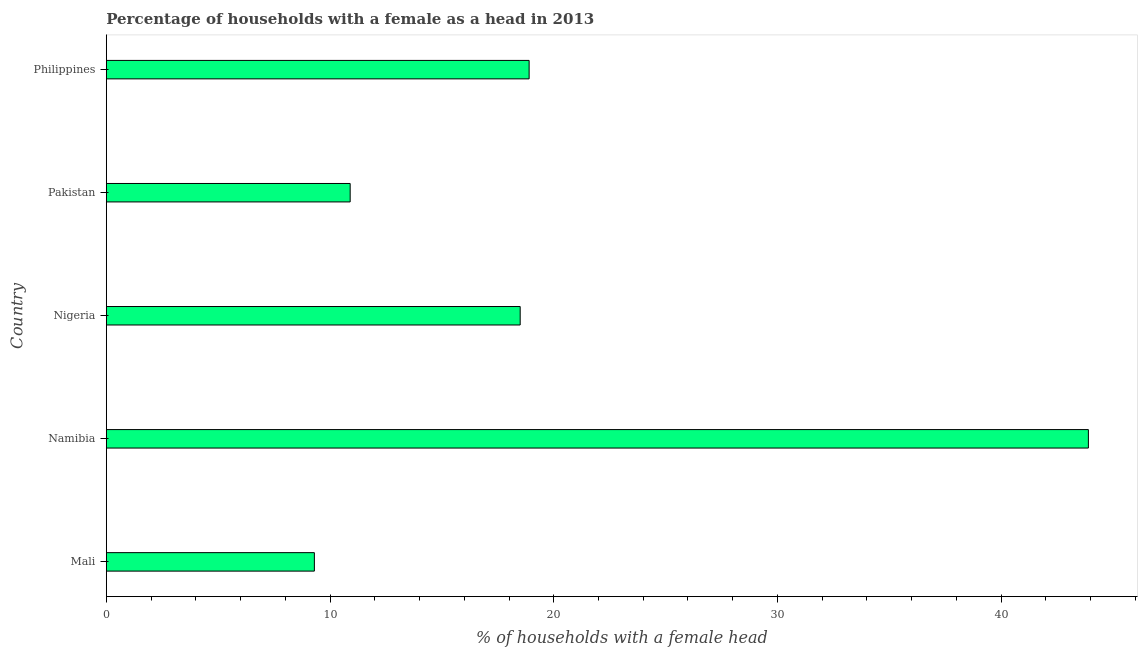Does the graph contain any zero values?
Your answer should be very brief. No. Does the graph contain grids?
Ensure brevity in your answer.  No. What is the title of the graph?
Provide a short and direct response. Percentage of households with a female as a head in 2013. What is the label or title of the X-axis?
Your answer should be compact. % of households with a female head. What is the number of female supervised households in Philippines?
Offer a terse response. 18.9. Across all countries, what is the maximum number of female supervised households?
Your answer should be very brief. 43.9. Across all countries, what is the minimum number of female supervised households?
Provide a succinct answer. 9.3. In which country was the number of female supervised households maximum?
Your answer should be compact. Namibia. In which country was the number of female supervised households minimum?
Make the answer very short. Mali. What is the sum of the number of female supervised households?
Ensure brevity in your answer.  101.5. What is the difference between the number of female supervised households in Namibia and Nigeria?
Make the answer very short. 25.4. What is the average number of female supervised households per country?
Offer a terse response. 20.3. What is the median number of female supervised households?
Your answer should be very brief. 18.5. What is the ratio of the number of female supervised households in Nigeria to that in Philippines?
Your answer should be compact. 0.98. What is the difference between the highest and the second highest number of female supervised households?
Make the answer very short. 25. What is the difference between the highest and the lowest number of female supervised households?
Your answer should be very brief. 34.6. In how many countries, is the number of female supervised households greater than the average number of female supervised households taken over all countries?
Give a very brief answer. 1. What is the difference between two consecutive major ticks on the X-axis?
Your answer should be compact. 10. Are the values on the major ticks of X-axis written in scientific E-notation?
Your answer should be compact. No. What is the % of households with a female head in Mali?
Make the answer very short. 9.3. What is the % of households with a female head in Namibia?
Provide a short and direct response. 43.9. What is the % of households with a female head in Philippines?
Offer a very short reply. 18.9. What is the difference between the % of households with a female head in Mali and Namibia?
Make the answer very short. -34.6. What is the difference between the % of households with a female head in Mali and Philippines?
Make the answer very short. -9.6. What is the difference between the % of households with a female head in Namibia and Nigeria?
Ensure brevity in your answer.  25.4. What is the difference between the % of households with a female head in Namibia and Pakistan?
Keep it short and to the point. 33. What is the difference between the % of households with a female head in Namibia and Philippines?
Give a very brief answer. 25. What is the difference between the % of households with a female head in Pakistan and Philippines?
Provide a succinct answer. -8. What is the ratio of the % of households with a female head in Mali to that in Namibia?
Provide a succinct answer. 0.21. What is the ratio of the % of households with a female head in Mali to that in Nigeria?
Keep it short and to the point. 0.5. What is the ratio of the % of households with a female head in Mali to that in Pakistan?
Your answer should be very brief. 0.85. What is the ratio of the % of households with a female head in Mali to that in Philippines?
Offer a terse response. 0.49. What is the ratio of the % of households with a female head in Namibia to that in Nigeria?
Your answer should be compact. 2.37. What is the ratio of the % of households with a female head in Namibia to that in Pakistan?
Keep it short and to the point. 4.03. What is the ratio of the % of households with a female head in Namibia to that in Philippines?
Provide a succinct answer. 2.32. What is the ratio of the % of households with a female head in Nigeria to that in Pakistan?
Your answer should be compact. 1.7. What is the ratio of the % of households with a female head in Nigeria to that in Philippines?
Provide a succinct answer. 0.98. What is the ratio of the % of households with a female head in Pakistan to that in Philippines?
Offer a terse response. 0.58. 